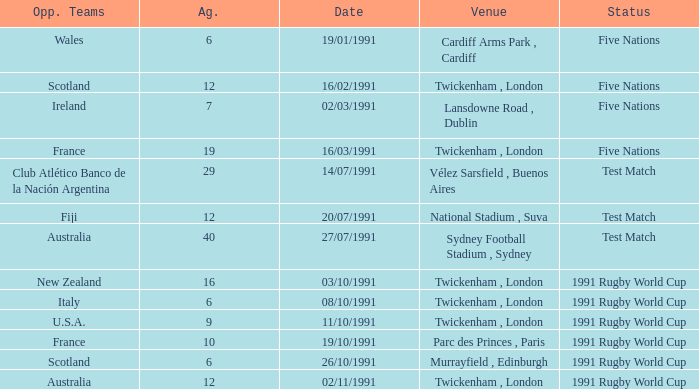What is Date, when Opposing Teams is "Australia", and when Venue is "Twickenham , London"? 02/11/1991. 